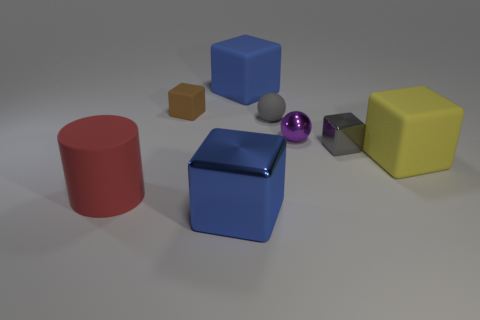There is a blue block that is in front of the purple sphere; does it have the same size as the large red rubber object?
Your answer should be compact. Yes. There is a brown matte thing that is the same size as the gray sphere; what is its shape?
Your answer should be very brief. Cube. Is the shape of the blue metallic thing the same as the tiny purple shiny object?
Provide a short and direct response. No. What number of other objects have the same shape as the small gray matte object?
Your answer should be very brief. 1. There is a large blue rubber block; how many purple metallic balls are behind it?
Make the answer very short. 0. There is a metal block that is behind the yellow thing; is its color the same as the large matte cylinder?
Provide a succinct answer. No. What number of gray objects are the same size as the yellow rubber block?
Make the answer very short. 0. There is a large yellow object that is made of the same material as the big red cylinder; what shape is it?
Provide a succinct answer. Cube. Is there a tiny matte ball that has the same color as the cylinder?
Provide a succinct answer. No. What material is the tiny gray cube?
Provide a short and direct response. Metal. 